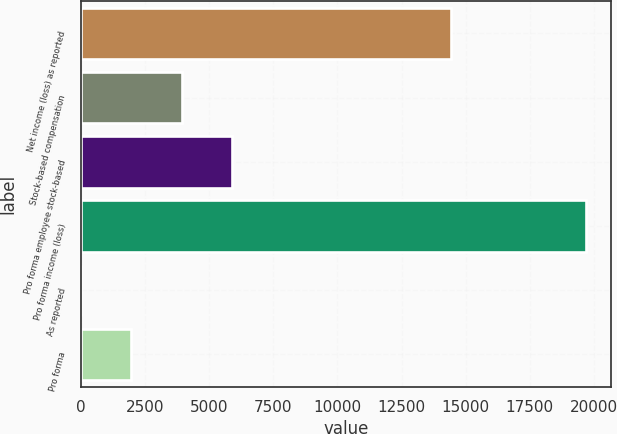Convert chart. <chart><loc_0><loc_0><loc_500><loc_500><bar_chart><fcel>Net income (loss) as reported<fcel>Stock-based compensation<fcel>Pro forma employee stock-based<fcel>Pro forma income (loss)<fcel>As reported<fcel>Pro forma<nl><fcel>14418<fcel>3933.94<fcel>5900.82<fcel>19669<fcel>0.18<fcel>1967.06<nl></chart> 